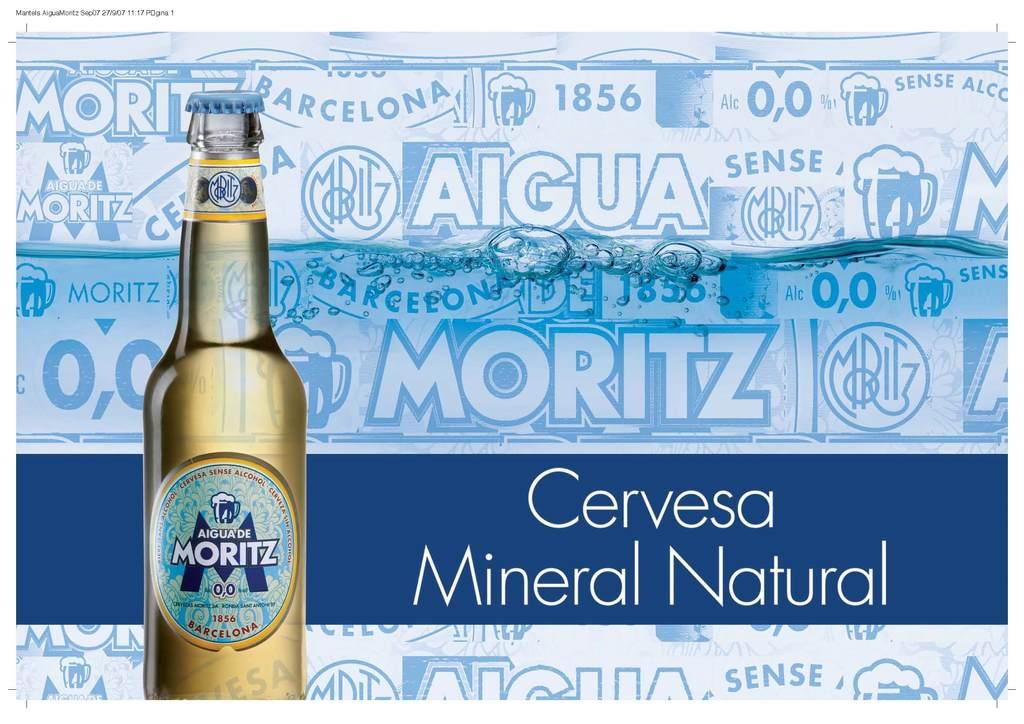<image>
Create a compact narrative representing the image presented. A poster featuring a bottle with the words Aiguade Moritz on it. 